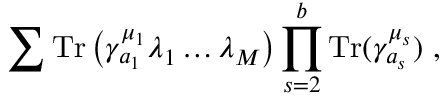<formula> <loc_0><loc_0><loc_500><loc_500>\sum T r \left ( \gamma _ { a _ { 1 } } ^ { \mu _ { 1 } } \lambda _ { 1 } \dots \lambda _ { M } \right ) \prod _ { s = 2 } ^ { b } T r ( \gamma _ { a _ { s } } ^ { \mu _ { s } } ) ,</formula> 